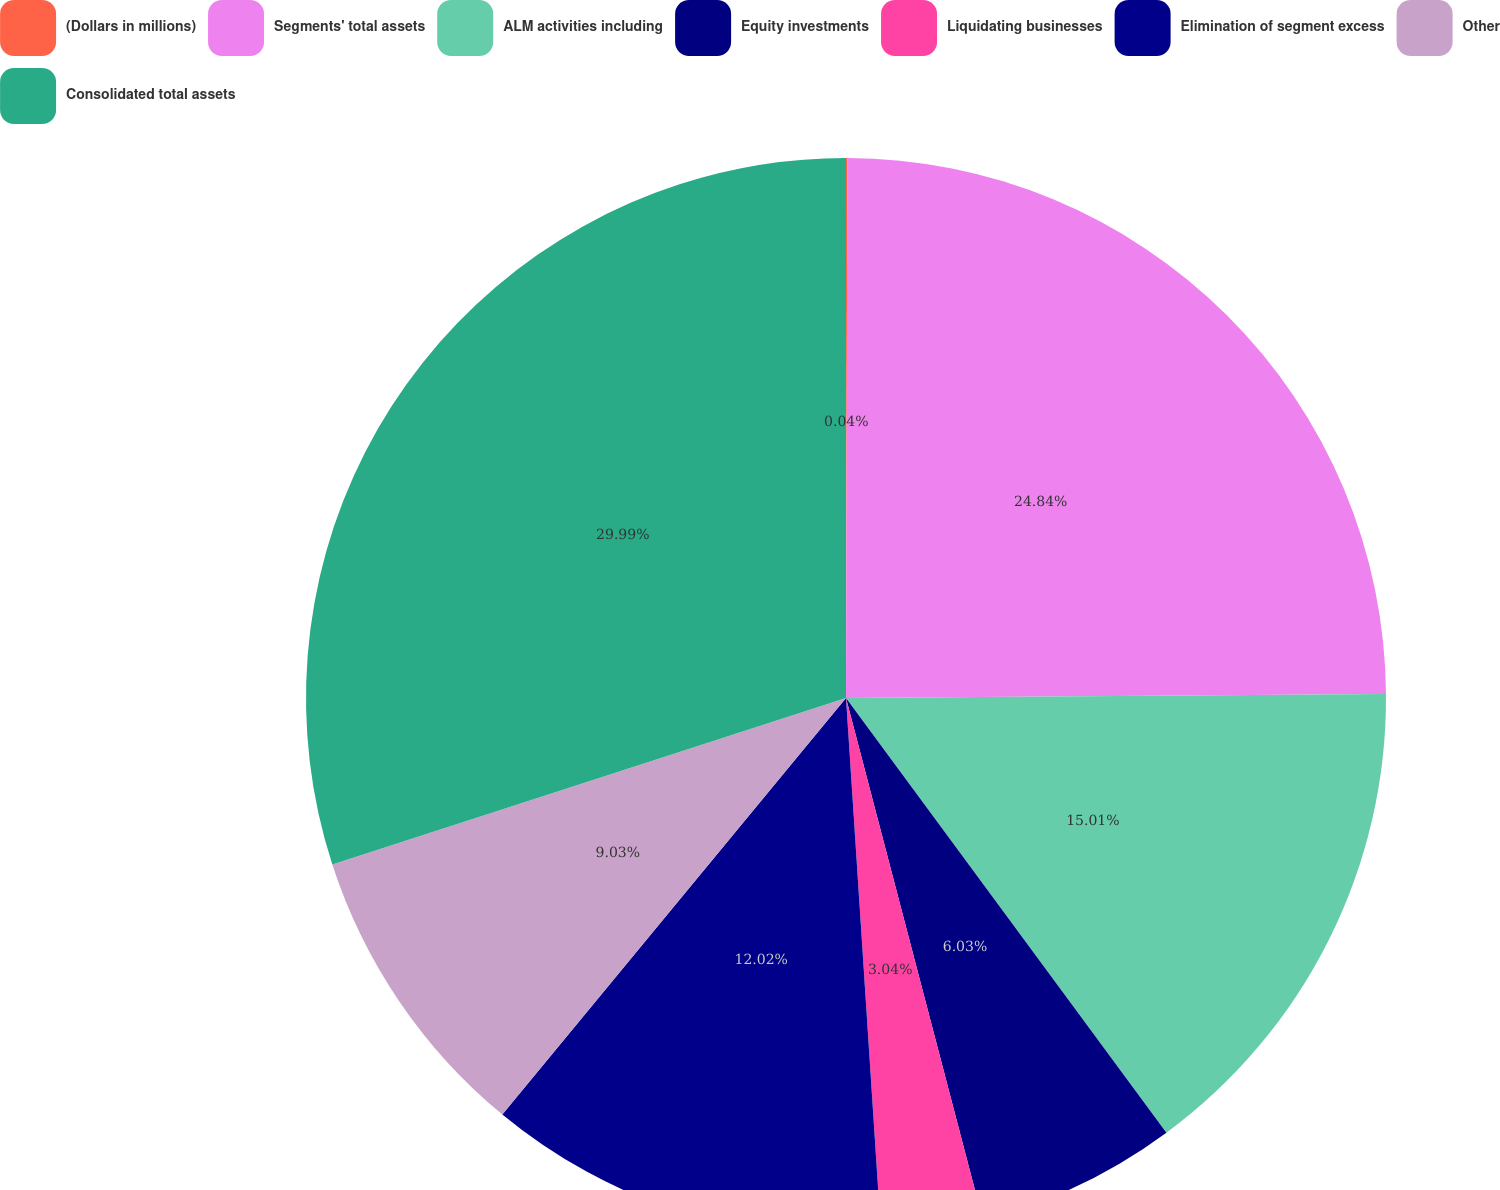Convert chart. <chart><loc_0><loc_0><loc_500><loc_500><pie_chart><fcel>(Dollars in millions)<fcel>Segments' total assets<fcel>ALM activities including<fcel>Equity investments<fcel>Liquidating businesses<fcel>Elimination of segment excess<fcel>Other<fcel>Consolidated total assets<nl><fcel>0.04%<fcel>24.84%<fcel>15.01%<fcel>6.03%<fcel>3.04%<fcel>12.02%<fcel>9.03%<fcel>29.99%<nl></chart> 